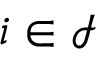<formula> <loc_0><loc_0><loc_500><loc_500>i \in \mathcal { I }</formula> 